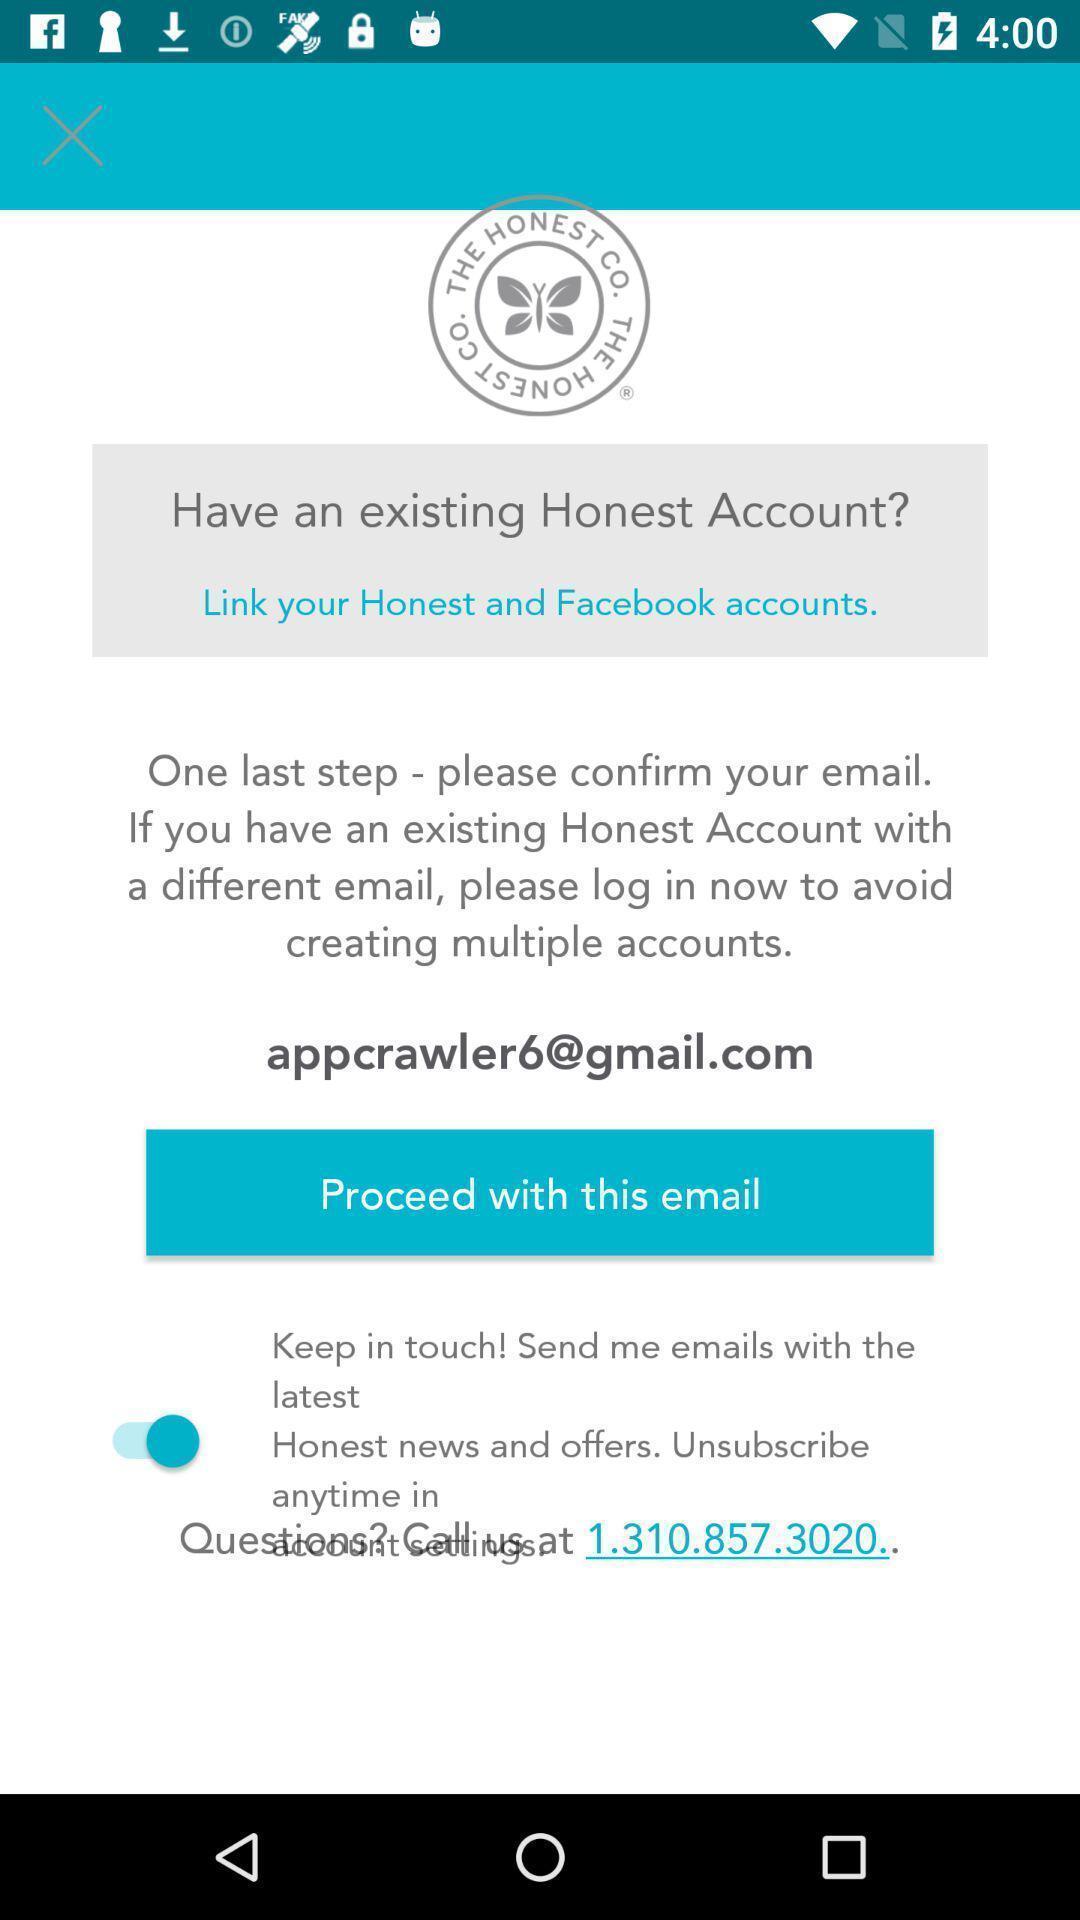Describe the visual elements of this screenshot. Page showing an option of proceed with this email. 